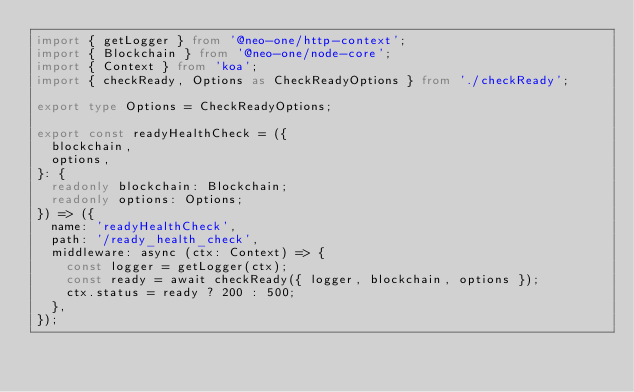<code> <loc_0><loc_0><loc_500><loc_500><_TypeScript_>import { getLogger } from '@neo-one/http-context';
import { Blockchain } from '@neo-one/node-core';
import { Context } from 'koa';
import { checkReady, Options as CheckReadyOptions } from './checkReady';

export type Options = CheckReadyOptions;

export const readyHealthCheck = ({
  blockchain,
  options,
}: {
  readonly blockchain: Blockchain;
  readonly options: Options;
}) => ({
  name: 'readyHealthCheck',
  path: '/ready_health_check',
  middleware: async (ctx: Context) => {
    const logger = getLogger(ctx);
    const ready = await checkReady({ logger, blockchain, options });
    ctx.status = ready ? 200 : 500;
  },
});
</code> 